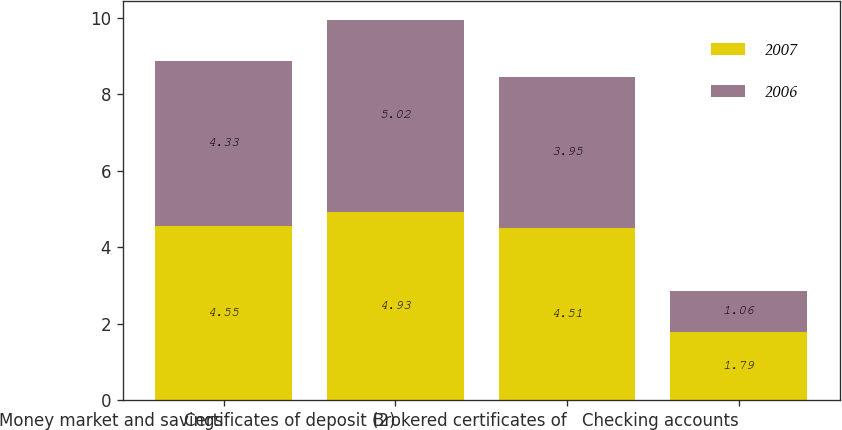<chart> <loc_0><loc_0><loc_500><loc_500><stacked_bar_chart><ecel><fcel>Money market and savings<fcel>Certificates of deposit (2)<fcel>Brokered certificates of<fcel>Checking accounts<nl><fcel>2007<fcel>4.55<fcel>4.93<fcel>4.51<fcel>1.79<nl><fcel>2006<fcel>4.33<fcel>5.02<fcel>3.95<fcel>1.06<nl></chart> 